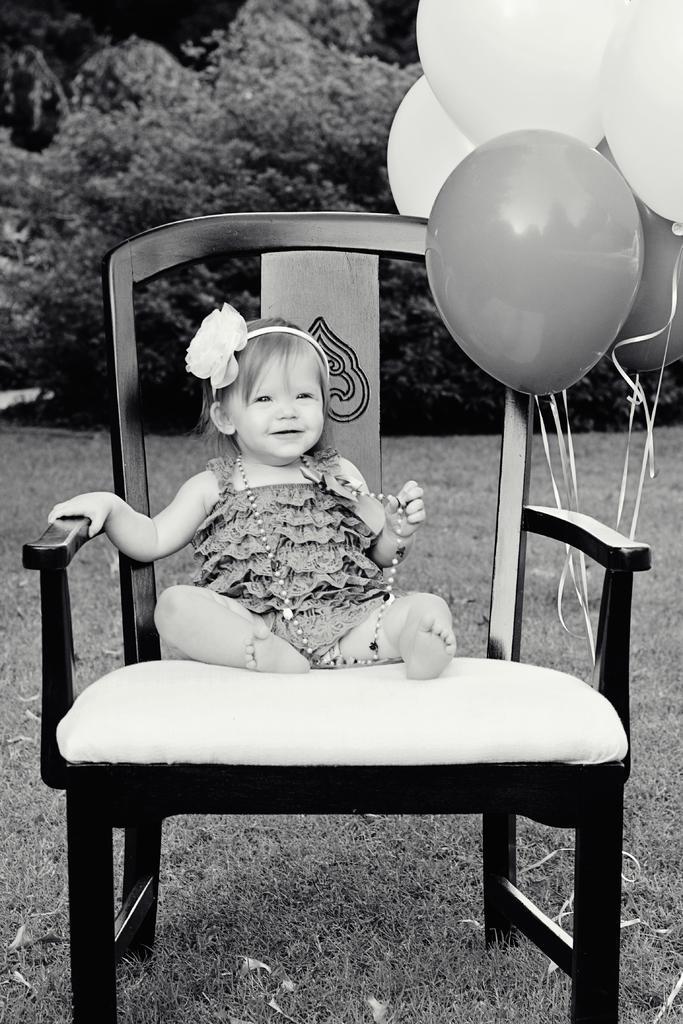How would you summarize this image in a sentence or two? In the image there is a baby sat on chair and balloons are tied to the chair. On the background there are plants and the floor is of grass. 